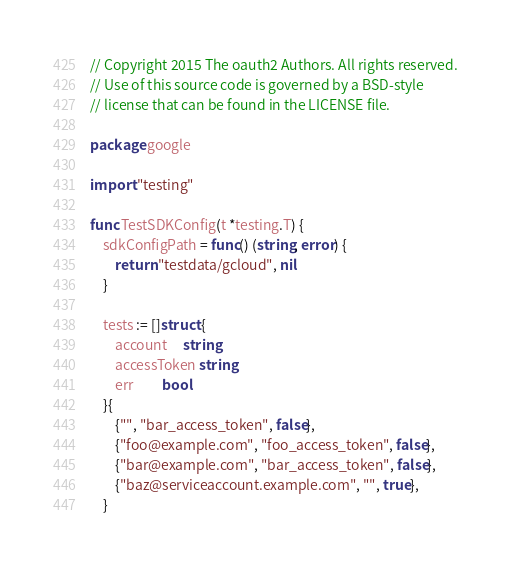Convert code to text. <code><loc_0><loc_0><loc_500><loc_500><_Go_>// Copyright 2015 The oauth2 Authors. All rights reserved.
// Use of this source code is governed by a BSD-style
// license that can be found in the LICENSE file.

package google

import "testing"

func TestSDKConfig(t *testing.T) {
	sdkConfigPath = func() (string, error) {
		return "testdata/gcloud", nil
	}

	tests := []struct {
		account     string
		accessToken string
		err         bool
	}{
		{"", "bar_access_token", false},
		{"foo@example.com", "foo_access_token", false},
		{"bar@example.com", "bar_access_token", false},
		{"baz@serviceaccount.example.com", "", true},
	}</code> 